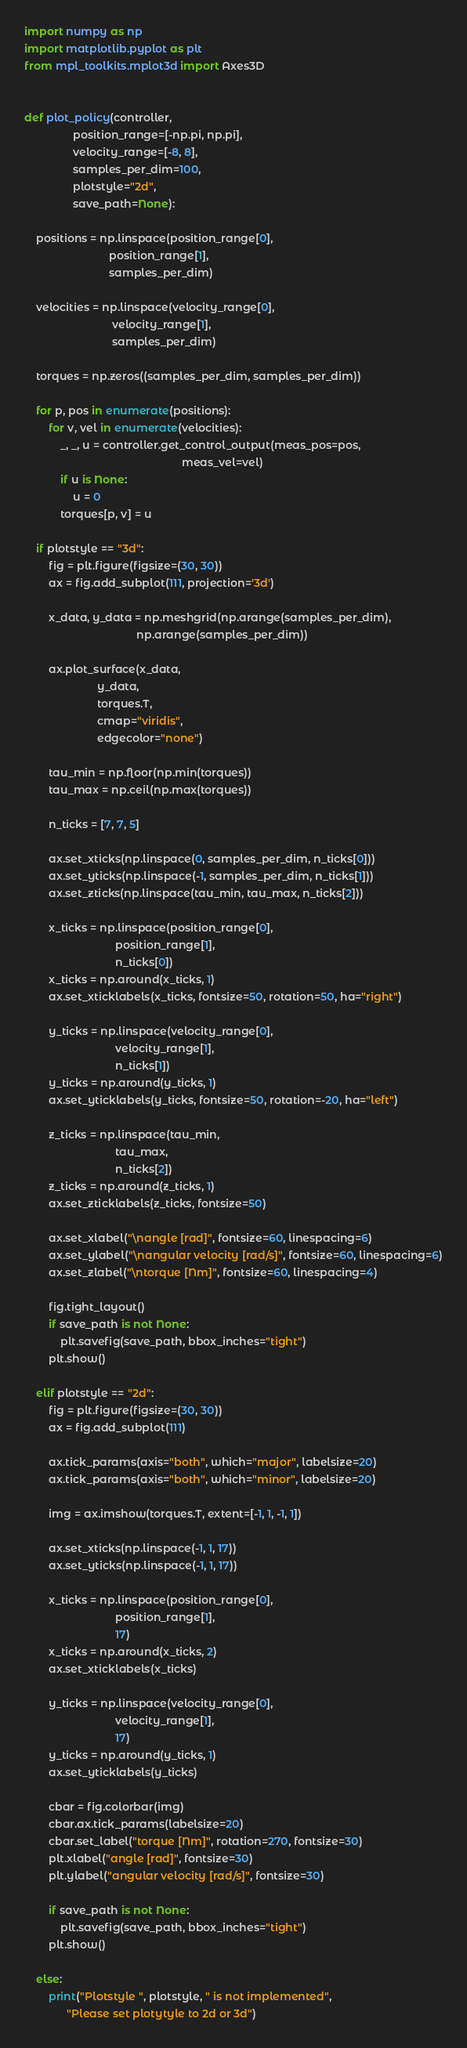Convert code to text. <code><loc_0><loc_0><loc_500><loc_500><_Python_>import numpy as np
import matplotlib.pyplot as plt
from mpl_toolkits.mplot3d import Axes3D


def plot_policy(controller,
                position_range=[-np.pi, np.pi],
                velocity_range=[-8, 8],
                samples_per_dim=100,
                plotstyle="2d",
                save_path=None):

    positions = np.linspace(position_range[0],
                            position_range[1],
                            samples_per_dim)

    velocities = np.linspace(velocity_range[0],
                             velocity_range[1],
                             samples_per_dim)

    torques = np.zeros((samples_per_dim, samples_per_dim))

    for p, pos in enumerate(positions):
        for v, vel in enumerate(velocities):
            _, _, u = controller.get_control_output(meas_pos=pos,
                                                    meas_vel=vel)
            if u is None:
                u = 0
            torques[p, v] = u

    if plotstyle == "3d":
        fig = plt.figure(figsize=(30, 30))
        ax = fig.add_subplot(111, projection='3d')

        x_data, y_data = np.meshgrid(np.arange(samples_per_dim),
                                     np.arange(samples_per_dim))

        ax.plot_surface(x_data,
                        y_data,
                        torques.T,
                        cmap="viridis",
                        edgecolor="none")

        tau_min = np.floor(np.min(torques))
        tau_max = np.ceil(np.max(torques))

        n_ticks = [7, 7, 5]

        ax.set_xticks(np.linspace(0, samples_per_dim, n_ticks[0]))
        ax.set_yticks(np.linspace(-1, samples_per_dim, n_ticks[1]))
        ax.set_zticks(np.linspace(tau_min, tau_max, n_ticks[2]))

        x_ticks = np.linspace(position_range[0],
                              position_range[1],
                              n_ticks[0])
        x_ticks = np.around(x_ticks, 1)
        ax.set_xticklabels(x_ticks, fontsize=50, rotation=50, ha="right")

        y_ticks = np.linspace(velocity_range[0],
                              velocity_range[1],
                              n_ticks[1])
        y_ticks = np.around(y_ticks, 1)
        ax.set_yticklabels(y_ticks, fontsize=50, rotation=-20, ha="left")

        z_ticks = np.linspace(tau_min,
                              tau_max,
                              n_ticks[2])
        z_ticks = np.around(z_ticks, 1)
        ax.set_zticklabels(z_ticks, fontsize=50)

        ax.set_xlabel("\nangle [rad]", fontsize=60, linespacing=6)
        ax.set_ylabel("\nangular velocity [rad/s]", fontsize=60, linespacing=6)
        ax.set_zlabel("\ntorque [Nm]", fontsize=60, linespacing=4)

        fig.tight_layout()
        if save_path is not None:
            plt.savefig(save_path, bbox_inches="tight")
        plt.show()

    elif plotstyle == "2d":
        fig = plt.figure(figsize=(30, 30))
        ax = fig.add_subplot(111)

        ax.tick_params(axis="both", which="major", labelsize=20)
        ax.tick_params(axis="both", which="minor", labelsize=20)

        img = ax.imshow(torques.T, extent=[-1, 1, -1, 1])

        ax.set_xticks(np.linspace(-1, 1, 17))
        ax.set_yticks(np.linspace(-1, 1, 17))

        x_ticks = np.linspace(position_range[0],
                              position_range[1],
                              17)
        x_ticks = np.around(x_ticks, 2)
        ax.set_xticklabels(x_ticks)

        y_ticks = np.linspace(velocity_range[0],
                              velocity_range[1],
                              17)
        y_ticks = np.around(y_ticks, 1)
        ax.set_yticklabels(y_ticks)

        cbar = fig.colorbar(img)
        cbar.ax.tick_params(labelsize=20)
        cbar.set_label("torque [Nm]", rotation=270, fontsize=30)
        plt.xlabel("angle [rad]", fontsize=30)
        plt.ylabel("angular velocity [rad/s]", fontsize=30)

        if save_path is not None:
            plt.savefig(save_path, bbox_inches="tight")
        plt.show()

    else:
        print("Plotstyle ", plotstyle, " is not implemented",
              "Please set plotytyle to 2d or 3d")
</code> 